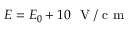Convert formula to latex. <formula><loc_0><loc_0><loc_500><loc_500>E = E _ { 0 } + 1 0 V / c m</formula> 